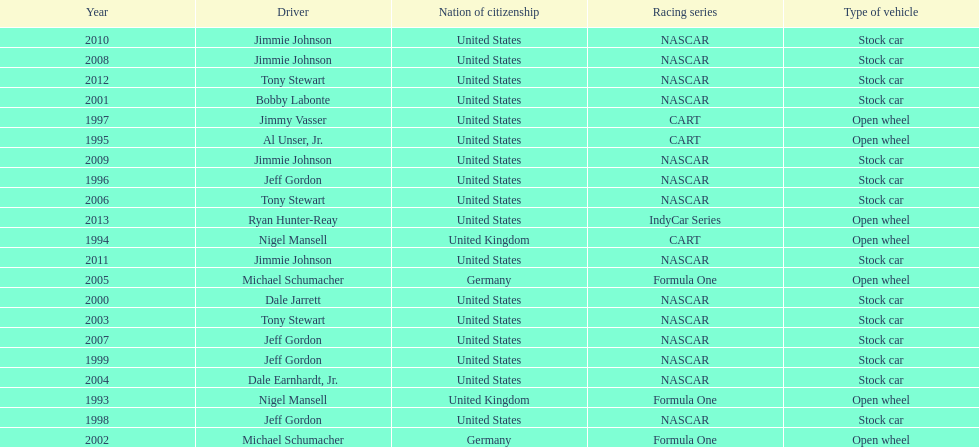How many total row entries are there? 21. 